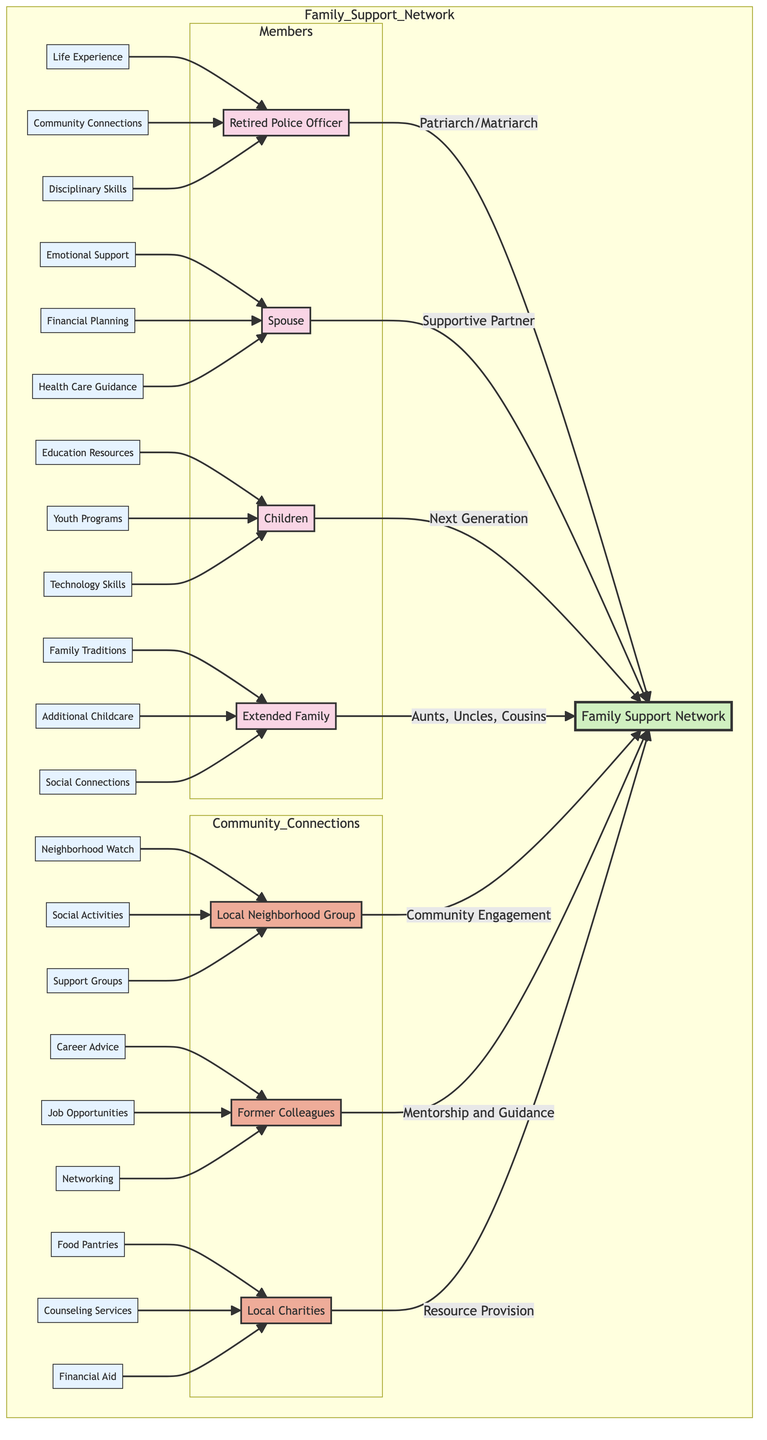What is the role of the Retired Police Officer? The diagram indicates the Retired Police Officer serves as the "Patriarch/Matriarch" within the family support network. This specific role signifies a leadership position within the family structure.
Answer: Patriarch/Matriarch How many members are listed in the Family Support Network? The diagram contains four specific members categorized under "Members": Retired Police Officer, Spouse, Children, and Extended Family. Thus, counting these leads to a total of four members.
Answer: 4 What is one resource available to the Spouse? The diagram outlines three resources associated with the Spouse, which are Emotional Support, Financial Planning, and Health Care Guidance. Any one of these can be cited as a resource, so selecting one gives us Emotional Support as an example.
Answer: Emotional Support Which community group provides mentorship and guidance? Among the community connections illustrated, the "Former Colleagues" group is explicitly identified as providing "Mentorship and Guidance." This designated role reflects their professional connection and supportive capacity.
Answer: Former Colleagues What resource is linked to Local Charities? The diagram states that Local Charities offer three resources: Food Pantries, Counseling Services, and Financial Aid. Any of these can serve as an answer, and selecting "Counseling Services" indicates their role in resource provision.
Answer: Counseling Services How is the relationship structured between the Children and the Family Support Network? The diagram indicates that the Children have the role of "Next Generation" which connects them directly to the Family Support Network (FSN). This relationship emphasizes their generational link to the core support system, showcasing continuity within the family.
Answer: Next Generation Which role specifically focuses on community engagement? In the community connections section, the "Local Neighborhood Group" is explicitly designated with the role centered on "Community Engagement." This highlights their focus on bringing community members together for various activities.
Answer: Community Engagement How many resources does the Extended Family contribute? The diagram shows three distinct resources associated with the Extended Family: Family Traditions, Additional Childcare, and Social Connections. Counting these resources, we find that the Extended Family contributes three resources in total.
Answer: 3 Which resource connects to the Retired Police Officer's disciplinary skills? The Retired Police Officer's resources include Life Experience, Community Connections, and Disciplinary Skills. "Disciplinary Skills" is explicitly listed as one of the resources, showing its importance to the officer’s role.
Answer: Disciplinary Skills 